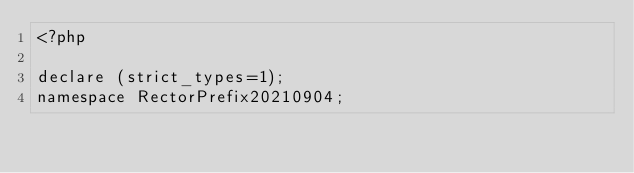Convert code to text. <code><loc_0><loc_0><loc_500><loc_500><_PHP_><?php

declare (strict_types=1);
namespace RectorPrefix20210904;
</code> 